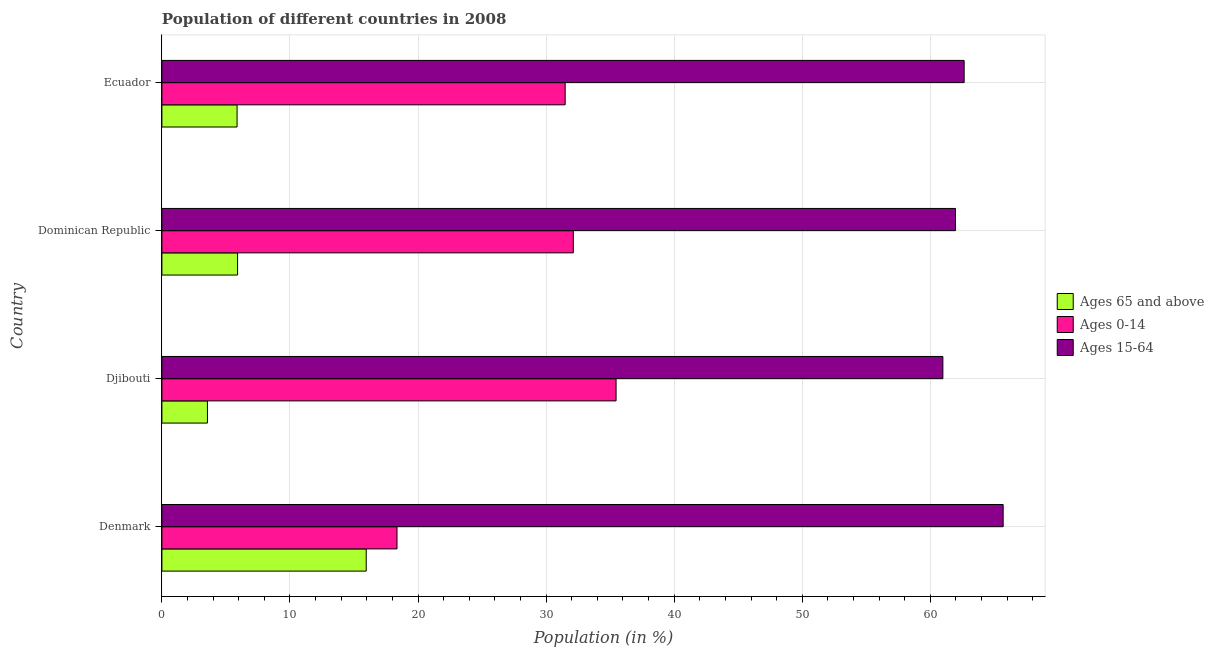How many different coloured bars are there?
Give a very brief answer. 3. Are the number of bars per tick equal to the number of legend labels?
Ensure brevity in your answer.  Yes. Are the number of bars on each tick of the Y-axis equal?
Your answer should be very brief. Yes. What is the label of the 2nd group of bars from the top?
Your answer should be compact. Dominican Republic. What is the percentage of population within the age-group 0-14 in Ecuador?
Your response must be concise. 31.49. Across all countries, what is the maximum percentage of population within the age-group 0-14?
Provide a succinct answer. 35.46. Across all countries, what is the minimum percentage of population within the age-group 15-64?
Offer a terse response. 60.98. In which country was the percentage of population within the age-group 0-14 maximum?
Provide a succinct answer. Djibouti. In which country was the percentage of population within the age-group 15-64 minimum?
Provide a succinct answer. Djibouti. What is the total percentage of population within the age-group of 65 and above in the graph?
Give a very brief answer. 31.29. What is the difference between the percentage of population within the age-group of 65 and above in Djibouti and that in Dominican Republic?
Provide a short and direct response. -2.35. What is the difference between the percentage of population within the age-group 0-14 in Ecuador and the percentage of population within the age-group 15-64 in Denmark?
Your answer should be compact. -34.2. What is the average percentage of population within the age-group 0-14 per country?
Provide a succinct answer. 29.36. What is the difference between the percentage of population within the age-group of 65 and above and percentage of population within the age-group 0-14 in Djibouti?
Keep it short and to the point. -31.91. In how many countries, is the percentage of population within the age-group of 65 and above greater than 38 %?
Your answer should be very brief. 0. What is the ratio of the percentage of population within the age-group of 65 and above in Denmark to that in Djibouti?
Give a very brief answer. 4.49. Is the percentage of population within the age-group 15-64 in Denmark less than that in Djibouti?
Your response must be concise. No. What is the difference between the highest and the second highest percentage of population within the age-group 15-64?
Ensure brevity in your answer.  3.05. What is the difference between the highest and the lowest percentage of population within the age-group 0-14?
Offer a very short reply. 17.11. Is the sum of the percentage of population within the age-group of 65 and above in Denmark and Dominican Republic greater than the maximum percentage of population within the age-group 0-14 across all countries?
Ensure brevity in your answer.  No. What does the 1st bar from the top in Dominican Republic represents?
Keep it short and to the point. Ages 15-64. What does the 1st bar from the bottom in Dominican Republic represents?
Your response must be concise. Ages 65 and above. How many bars are there?
Provide a short and direct response. 12. Are all the bars in the graph horizontal?
Offer a very short reply. Yes. Does the graph contain any zero values?
Make the answer very short. No. Where does the legend appear in the graph?
Provide a succinct answer. Center right. What is the title of the graph?
Ensure brevity in your answer.  Population of different countries in 2008. Does "Nuclear sources" appear as one of the legend labels in the graph?
Your response must be concise. No. What is the label or title of the Y-axis?
Ensure brevity in your answer.  Country. What is the Population (in %) in Ages 65 and above in Denmark?
Offer a very short reply. 15.95. What is the Population (in %) of Ages 0-14 in Denmark?
Keep it short and to the point. 18.36. What is the Population (in %) of Ages 15-64 in Denmark?
Provide a succinct answer. 65.69. What is the Population (in %) in Ages 65 and above in Djibouti?
Ensure brevity in your answer.  3.56. What is the Population (in %) in Ages 0-14 in Djibouti?
Keep it short and to the point. 35.46. What is the Population (in %) in Ages 15-64 in Djibouti?
Your response must be concise. 60.98. What is the Population (in %) in Ages 65 and above in Dominican Republic?
Provide a succinct answer. 5.91. What is the Population (in %) of Ages 0-14 in Dominican Republic?
Provide a succinct answer. 32.12. What is the Population (in %) of Ages 15-64 in Dominican Republic?
Provide a short and direct response. 61.97. What is the Population (in %) in Ages 65 and above in Ecuador?
Keep it short and to the point. 5.87. What is the Population (in %) in Ages 0-14 in Ecuador?
Your answer should be very brief. 31.49. What is the Population (in %) of Ages 15-64 in Ecuador?
Keep it short and to the point. 62.64. Across all countries, what is the maximum Population (in %) in Ages 65 and above?
Your answer should be compact. 15.95. Across all countries, what is the maximum Population (in %) of Ages 0-14?
Offer a very short reply. 35.46. Across all countries, what is the maximum Population (in %) in Ages 15-64?
Make the answer very short. 65.69. Across all countries, what is the minimum Population (in %) of Ages 65 and above?
Ensure brevity in your answer.  3.56. Across all countries, what is the minimum Population (in %) of Ages 0-14?
Give a very brief answer. 18.36. Across all countries, what is the minimum Population (in %) in Ages 15-64?
Offer a terse response. 60.98. What is the total Population (in %) of Ages 65 and above in the graph?
Make the answer very short. 31.29. What is the total Population (in %) in Ages 0-14 in the graph?
Your answer should be very brief. 117.43. What is the total Population (in %) of Ages 15-64 in the graph?
Offer a very short reply. 251.28. What is the difference between the Population (in %) in Ages 65 and above in Denmark and that in Djibouti?
Your response must be concise. 12.4. What is the difference between the Population (in %) of Ages 0-14 in Denmark and that in Djibouti?
Offer a very short reply. -17.11. What is the difference between the Population (in %) in Ages 15-64 in Denmark and that in Djibouti?
Keep it short and to the point. 4.71. What is the difference between the Population (in %) of Ages 65 and above in Denmark and that in Dominican Republic?
Your response must be concise. 10.04. What is the difference between the Population (in %) in Ages 0-14 in Denmark and that in Dominican Republic?
Ensure brevity in your answer.  -13.77. What is the difference between the Population (in %) of Ages 15-64 in Denmark and that in Dominican Republic?
Provide a succinct answer. 3.72. What is the difference between the Population (in %) in Ages 65 and above in Denmark and that in Ecuador?
Make the answer very short. 10.08. What is the difference between the Population (in %) of Ages 0-14 in Denmark and that in Ecuador?
Your answer should be compact. -13.13. What is the difference between the Population (in %) in Ages 15-64 in Denmark and that in Ecuador?
Make the answer very short. 3.05. What is the difference between the Population (in %) of Ages 65 and above in Djibouti and that in Dominican Republic?
Your answer should be very brief. -2.35. What is the difference between the Population (in %) of Ages 0-14 in Djibouti and that in Dominican Republic?
Make the answer very short. 3.34. What is the difference between the Population (in %) of Ages 15-64 in Djibouti and that in Dominican Republic?
Offer a very short reply. -0.99. What is the difference between the Population (in %) in Ages 65 and above in Djibouti and that in Ecuador?
Provide a short and direct response. -2.31. What is the difference between the Population (in %) in Ages 0-14 in Djibouti and that in Ecuador?
Keep it short and to the point. 3.97. What is the difference between the Population (in %) of Ages 15-64 in Djibouti and that in Ecuador?
Provide a short and direct response. -1.66. What is the difference between the Population (in %) in Ages 65 and above in Dominican Republic and that in Ecuador?
Provide a short and direct response. 0.04. What is the difference between the Population (in %) of Ages 0-14 in Dominican Republic and that in Ecuador?
Your response must be concise. 0.64. What is the difference between the Population (in %) of Ages 15-64 in Dominican Republic and that in Ecuador?
Your answer should be very brief. -0.67. What is the difference between the Population (in %) in Ages 65 and above in Denmark and the Population (in %) in Ages 0-14 in Djibouti?
Offer a terse response. -19.51. What is the difference between the Population (in %) in Ages 65 and above in Denmark and the Population (in %) in Ages 15-64 in Djibouti?
Offer a terse response. -45.03. What is the difference between the Population (in %) of Ages 0-14 in Denmark and the Population (in %) of Ages 15-64 in Djibouti?
Provide a short and direct response. -42.62. What is the difference between the Population (in %) in Ages 65 and above in Denmark and the Population (in %) in Ages 0-14 in Dominican Republic?
Your response must be concise. -16.17. What is the difference between the Population (in %) of Ages 65 and above in Denmark and the Population (in %) of Ages 15-64 in Dominican Republic?
Keep it short and to the point. -46.01. What is the difference between the Population (in %) of Ages 0-14 in Denmark and the Population (in %) of Ages 15-64 in Dominican Republic?
Ensure brevity in your answer.  -43.61. What is the difference between the Population (in %) of Ages 65 and above in Denmark and the Population (in %) of Ages 0-14 in Ecuador?
Give a very brief answer. -15.53. What is the difference between the Population (in %) in Ages 65 and above in Denmark and the Population (in %) in Ages 15-64 in Ecuador?
Provide a succinct answer. -46.69. What is the difference between the Population (in %) of Ages 0-14 in Denmark and the Population (in %) of Ages 15-64 in Ecuador?
Provide a succinct answer. -44.28. What is the difference between the Population (in %) in Ages 65 and above in Djibouti and the Population (in %) in Ages 0-14 in Dominican Republic?
Your answer should be very brief. -28.57. What is the difference between the Population (in %) in Ages 65 and above in Djibouti and the Population (in %) in Ages 15-64 in Dominican Republic?
Make the answer very short. -58.41. What is the difference between the Population (in %) in Ages 0-14 in Djibouti and the Population (in %) in Ages 15-64 in Dominican Republic?
Your answer should be very brief. -26.5. What is the difference between the Population (in %) in Ages 65 and above in Djibouti and the Population (in %) in Ages 0-14 in Ecuador?
Ensure brevity in your answer.  -27.93. What is the difference between the Population (in %) of Ages 65 and above in Djibouti and the Population (in %) of Ages 15-64 in Ecuador?
Make the answer very short. -59.09. What is the difference between the Population (in %) in Ages 0-14 in Djibouti and the Population (in %) in Ages 15-64 in Ecuador?
Your answer should be very brief. -27.18. What is the difference between the Population (in %) in Ages 65 and above in Dominican Republic and the Population (in %) in Ages 0-14 in Ecuador?
Give a very brief answer. -25.58. What is the difference between the Population (in %) in Ages 65 and above in Dominican Republic and the Population (in %) in Ages 15-64 in Ecuador?
Your answer should be very brief. -56.73. What is the difference between the Population (in %) in Ages 0-14 in Dominican Republic and the Population (in %) in Ages 15-64 in Ecuador?
Provide a succinct answer. -30.52. What is the average Population (in %) in Ages 65 and above per country?
Provide a short and direct response. 7.82. What is the average Population (in %) in Ages 0-14 per country?
Your answer should be compact. 29.36. What is the average Population (in %) in Ages 15-64 per country?
Ensure brevity in your answer.  62.82. What is the difference between the Population (in %) in Ages 65 and above and Population (in %) in Ages 0-14 in Denmark?
Offer a terse response. -2.4. What is the difference between the Population (in %) in Ages 65 and above and Population (in %) in Ages 15-64 in Denmark?
Give a very brief answer. -49.73. What is the difference between the Population (in %) in Ages 0-14 and Population (in %) in Ages 15-64 in Denmark?
Make the answer very short. -47.33. What is the difference between the Population (in %) of Ages 65 and above and Population (in %) of Ages 0-14 in Djibouti?
Offer a terse response. -31.91. What is the difference between the Population (in %) of Ages 65 and above and Population (in %) of Ages 15-64 in Djibouti?
Provide a short and direct response. -57.43. What is the difference between the Population (in %) of Ages 0-14 and Population (in %) of Ages 15-64 in Djibouti?
Offer a very short reply. -25.52. What is the difference between the Population (in %) of Ages 65 and above and Population (in %) of Ages 0-14 in Dominican Republic?
Offer a terse response. -26.21. What is the difference between the Population (in %) of Ages 65 and above and Population (in %) of Ages 15-64 in Dominican Republic?
Ensure brevity in your answer.  -56.06. What is the difference between the Population (in %) of Ages 0-14 and Population (in %) of Ages 15-64 in Dominican Republic?
Provide a short and direct response. -29.84. What is the difference between the Population (in %) of Ages 65 and above and Population (in %) of Ages 0-14 in Ecuador?
Give a very brief answer. -25.62. What is the difference between the Population (in %) in Ages 65 and above and Population (in %) in Ages 15-64 in Ecuador?
Your response must be concise. -56.77. What is the difference between the Population (in %) in Ages 0-14 and Population (in %) in Ages 15-64 in Ecuador?
Ensure brevity in your answer.  -31.15. What is the ratio of the Population (in %) of Ages 65 and above in Denmark to that in Djibouti?
Your answer should be very brief. 4.49. What is the ratio of the Population (in %) in Ages 0-14 in Denmark to that in Djibouti?
Offer a very short reply. 0.52. What is the ratio of the Population (in %) in Ages 15-64 in Denmark to that in Djibouti?
Your answer should be very brief. 1.08. What is the ratio of the Population (in %) of Ages 65 and above in Denmark to that in Dominican Republic?
Your answer should be compact. 2.7. What is the ratio of the Population (in %) in Ages 0-14 in Denmark to that in Dominican Republic?
Provide a succinct answer. 0.57. What is the ratio of the Population (in %) in Ages 15-64 in Denmark to that in Dominican Republic?
Offer a very short reply. 1.06. What is the ratio of the Population (in %) in Ages 65 and above in Denmark to that in Ecuador?
Provide a succinct answer. 2.72. What is the ratio of the Population (in %) in Ages 0-14 in Denmark to that in Ecuador?
Your answer should be very brief. 0.58. What is the ratio of the Population (in %) of Ages 15-64 in Denmark to that in Ecuador?
Offer a terse response. 1.05. What is the ratio of the Population (in %) of Ages 65 and above in Djibouti to that in Dominican Republic?
Your response must be concise. 0.6. What is the ratio of the Population (in %) of Ages 0-14 in Djibouti to that in Dominican Republic?
Make the answer very short. 1.1. What is the ratio of the Population (in %) in Ages 15-64 in Djibouti to that in Dominican Republic?
Offer a terse response. 0.98. What is the ratio of the Population (in %) of Ages 65 and above in Djibouti to that in Ecuador?
Your answer should be very brief. 0.61. What is the ratio of the Population (in %) of Ages 0-14 in Djibouti to that in Ecuador?
Your answer should be very brief. 1.13. What is the ratio of the Population (in %) of Ages 15-64 in Djibouti to that in Ecuador?
Ensure brevity in your answer.  0.97. What is the ratio of the Population (in %) in Ages 65 and above in Dominican Republic to that in Ecuador?
Ensure brevity in your answer.  1.01. What is the ratio of the Population (in %) of Ages 0-14 in Dominican Republic to that in Ecuador?
Ensure brevity in your answer.  1.02. What is the ratio of the Population (in %) of Ages 15-64 in Dominican Republic to that in Ecuador?
Your response must be concise. 0.99. What is the difference between the highest and the second highest Population (in %) of Ages 65 and above?
Offer a terse response. 10.04. What is the difference between the highest and the second highest Population (in %) of Ages 0-14?
Provide a succinct answer. 3.34. What is the difference between the highest and the second highest Population (in %) in Ages 15-64?
Your response must be concise. 3.05. What is the difference between the highest and the lowest Population (in %) in Ages 65 and above?
Your response must be concise. 12.4. What is the difference between the highest and the lowest Population (in %) of Ages 0-14?
Your answer should be compact. 17.11. What is the difference between the highest and the lowest Population (in %) in Ages 15-64?
Keep it short and to the point. 4.71. 